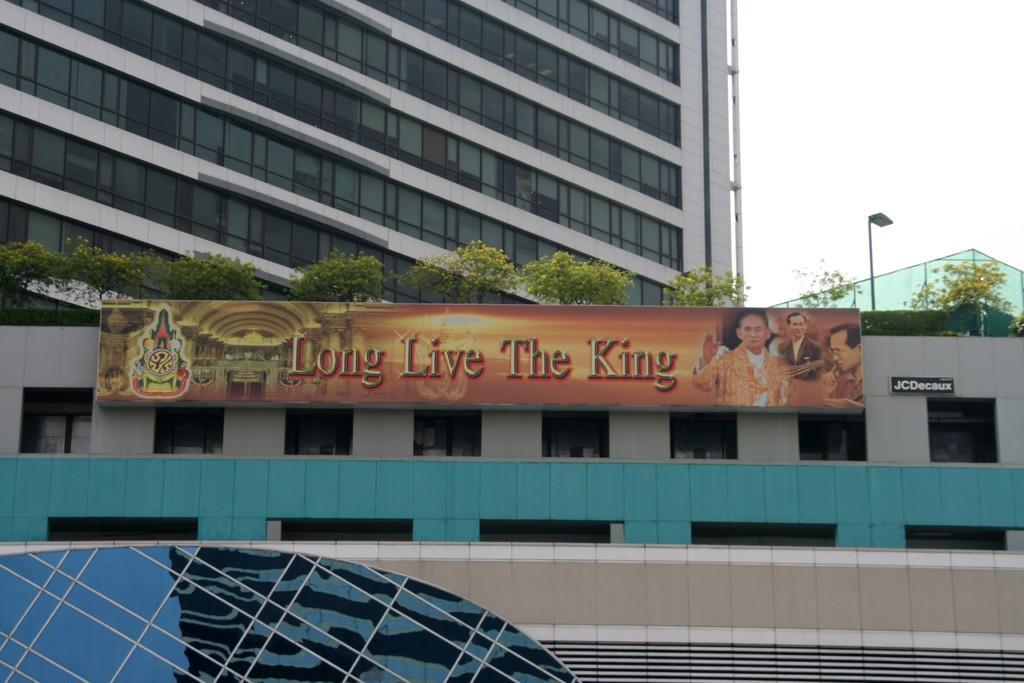Describe this image in one or two sentences. In this picture we can see buildings with windows, banner, trees, pole and in the background we can see the sky. 